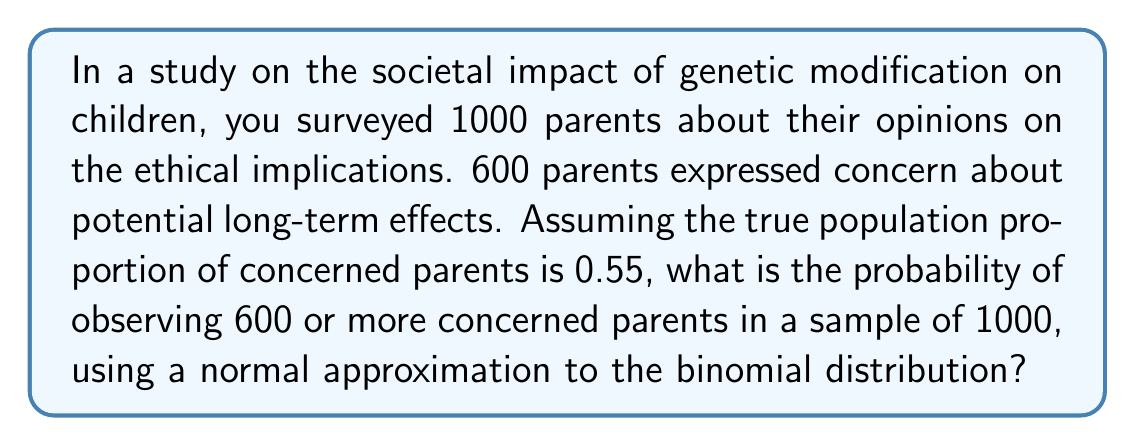Show me your answer to this math problem. To solve this problem, we'll use the normal approximation to the binomial distribution. Let's follow these steps:

1) First, we need to check if the normal approximation is appropriate:
   $n \cdot p > 10$ and $n \cdot (1-p) > 10$
   $1000 \cdot 0.55 = 550 > 10$ and $1000 \cdot 0.45 = 450 > 10$
   So, the normal approximation is valid.

2) Calculate the mean ($\mu$) and standard deviation ($\sigma$) of the normal distribution:
   $\mu = n \cdot p = 1000 \cdot 0.55 = 550$
   $\sigma = \sqrt{n \cdot p \cdot (1-p)} = \sqrt{1000 \cdot 0.55 \cdot 0.45} = \sqrt{247.5} \approx 15.73$

3) Calculate the z-score for 600 concerned parents:
   $z = \frac{x - \mu}{\sigma} = \frac{600 - 550}{15.73} \approx 3.18$

4) We want the probability of 600 or more, so we need P(X ≥ 600).
   This is equivalent to the area to the right of z = 3.18 on a standard normal distribution.

5) Using a standard normal table or calculator, we find:
   P(Z > 3.18) ≈ 0.0007

Therefore, the probability of observing 600 or more concerned parents in a sample of 1000, given a true population proportion of 0.55, is approximately 0.0007 or 0.07%.
Answer: 0.0007 